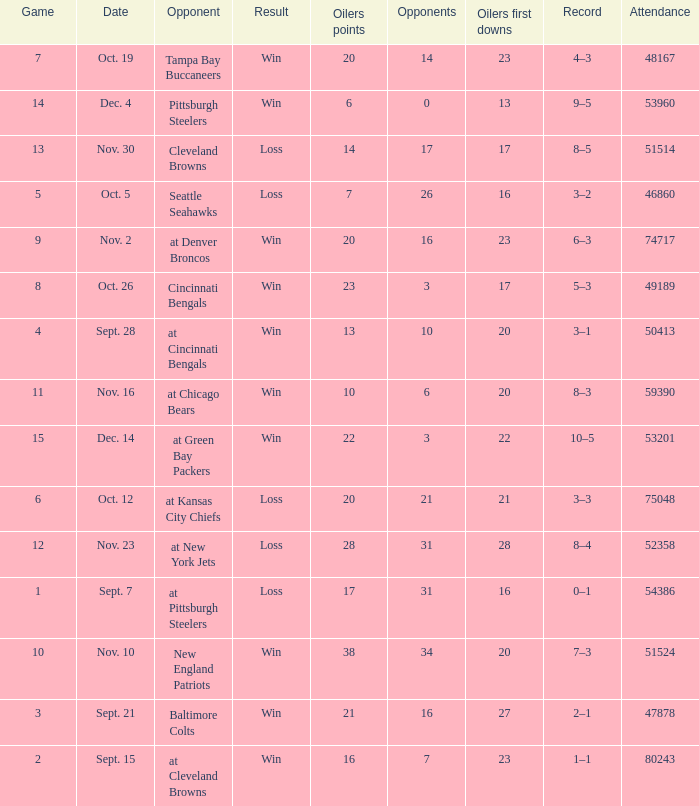What was the total opponents points for the game were the Oilers scored 21? 16.0. 